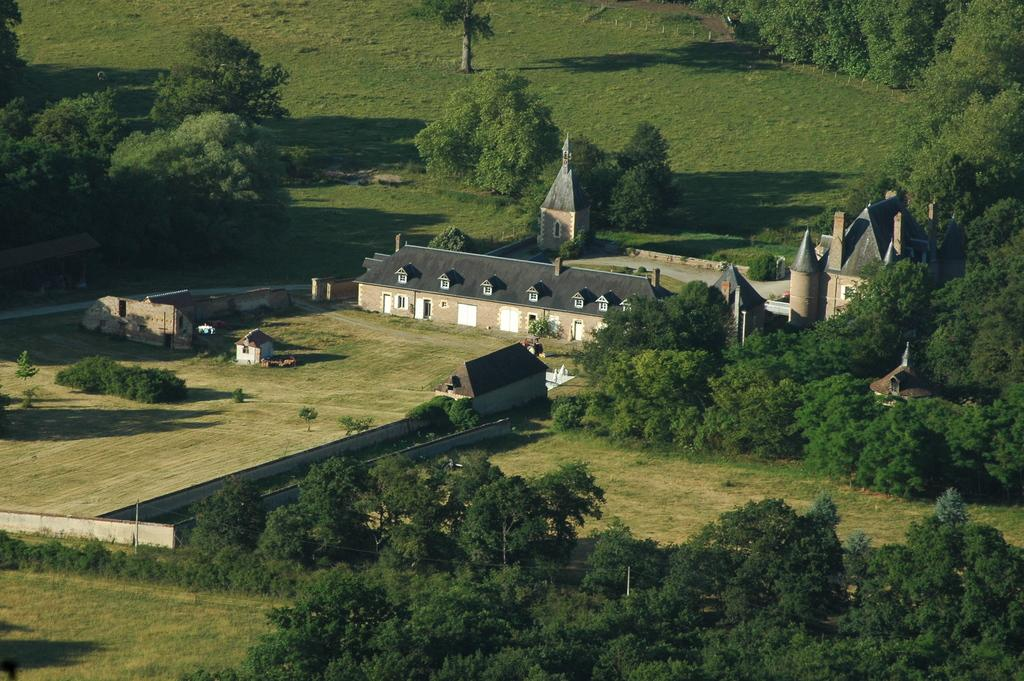What type of structure is visible in the image? There is a house in the image. What type of vegetation can be seen in the image? There are plants and trees in the image. What is covering the ground in the image? There is grass on the ground in the image. Where is the crate located in the image? There is no crate present in the image. What type of trip can be seen in the image? There is no trip visible in the image. 